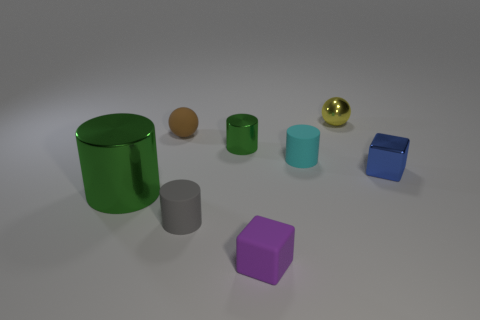Do the matte cylinder on the right side of the tiny purple matte block and the tiny cylinder behind the cyan object have the same color?
Your response must be concise. No. Are any small brown spheres visible?
Your response must be concise. Yes. What material is the small cylinder that is the same color as the big cylinder?
Offer a very short reply. Metal. There is a cube that is to the left of the small object behind the small ball in front of the metallic sphere; how big is it?
Keep it short and to the point. Small. There is a yellow object; is it the same shape as the tiny metallic object left of the metal sphere?
Give a very brief answer. No. Are there any blocks that have the same color as the matte ball?
Give a very brief answer. No. How many cylinders are either cyan matte objects or tiny green objects?
Give a very brief answer. 2. Are there any other blue metallic objects that have the same shape as the large thing?
Keep it short and to the point. No. How many other objects are there of the same color as the metallic block?
Provide a short and direct response. 0. Is the number of cyan things that are to the left of the brown thing less than the number of cyan matte objects?
Provide a short and direct response. Yes. 